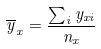Convert formula to latex. <formula><loc_0><loc_0><loc_500><loc_500>\overline { y } _ { x } = \frac { \sum _ { i } y _ { x i } } { n _ { x } }</formula> 